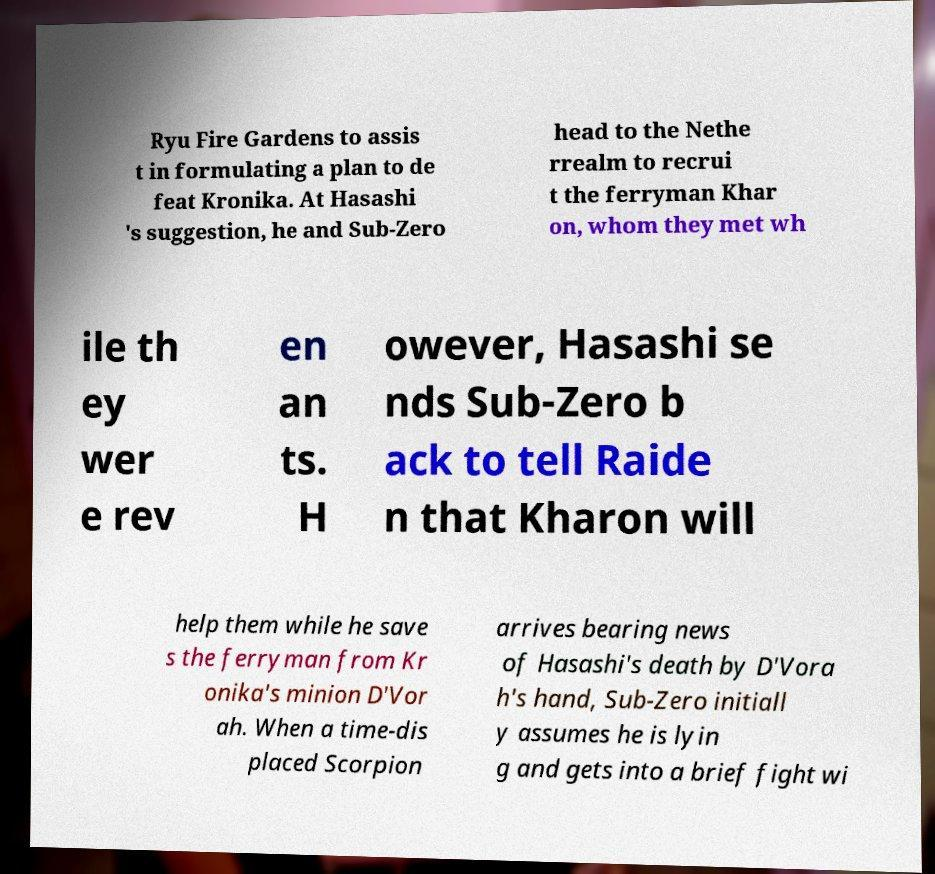For documentation purposes, I need the text within this image transcribed. Could you provide that? Ryu Fire Gardens to assis t in formulating a plan to de feat Kronika. At Hasashi 's suggestion, he and Sub-Zero head to the Nethe rrealm to recrui t the ferryman Khar on, whom they met wh ile th ey wer e rev en an ts. H owever, Hasashi se nds Sub-Zero b ack to tell Raide n that Kharon will help them while he save s the ferryman from Kr onika's minion D'Vor ah. When a time-dis placed Scorpion arrives bearing news of Hasashi's death by D'Vora h's hand, Sub-Zero initiall y assumes he is lyin g and gets into a brief fight wi 